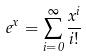<formula> <loc_0><loc_0><loc_500><loc_500>e ^ { x } = \sum _ { i = 0 } ^ { \infty } \frac { x ^ { i } } { i ! }</formula> 